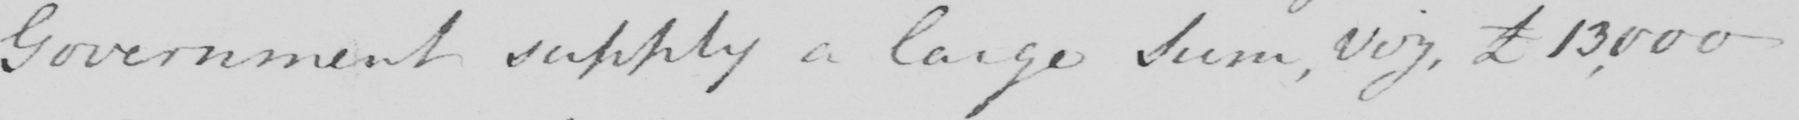What does this handwritten line say? Government supply a large Sum , viz , £13 ,000 